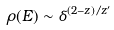<formula> <loc_0><loc_0><loc_500><loc_500>\rho ( E ) \sim \delta ^ { ( 2 - z ) / z ^ { \prime } }</formula> 